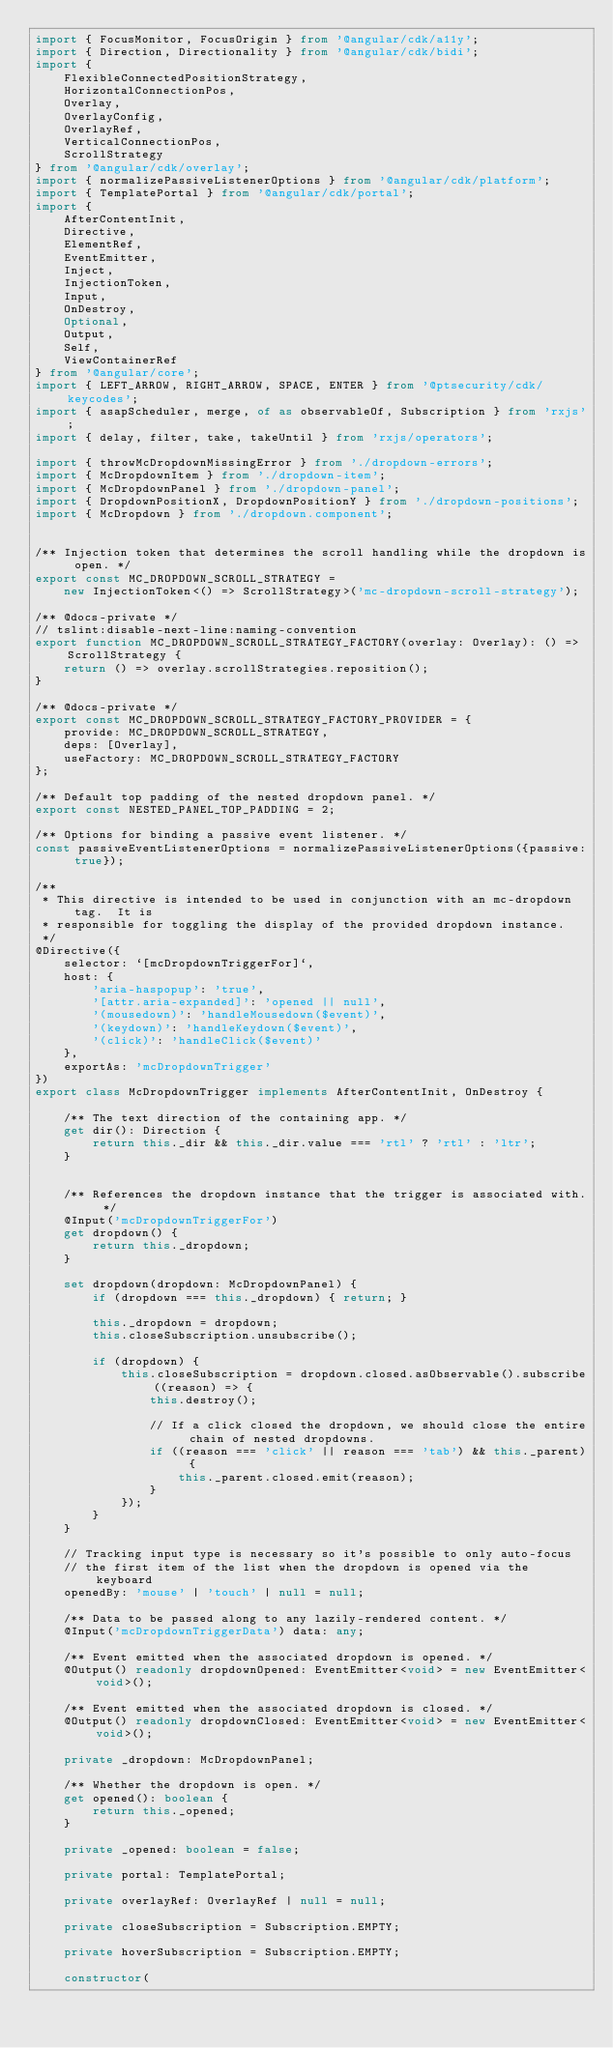<code> <loc_0><loc_0><loc_500><loc_500><_TypeScript_>import { FocusMonitor, FocusOrigin } from '@angular/cdk/a11y';
import { Direction, Directionality } from '@angular/cdk/bidi';
import {
    FlexibleConnectedPositionStrategy,
    HorizontalConnectionPos,
    Overlay,
    OverlayConfig,
    OverlayRef,
    VerticalConnectionPos,
    ScrollStrategy
} from '@angular/cdk/overlay';
import { normalizePassiveListenerOptions } from '@angular/cdk/platform';
import { TemplatePortal } from '@angular/cdk/portal';
import {
    AfterContentInit,
    Directive,
    ElementRef,
    EventEmitter,
    Inject,
    InjectionToken,
    Input,
    OnDestroy,
    Optional,
    Output,
    Self,
    ViewContainerRef
} from '@angular/core';
import { LEFT_ARROW, RIGHT_ARROW, SPACE, ENTER } from '@ptsecurity/cdk/keycodes';
import { asapScheduler, merge, of as observableOf, Subscription } from 'rxjs';
import { delay, filter, take, takeUntil } from 'rxjs/operators';

import { throwMcDropdownMissingError } from './dropdown-errors';
import { McDropdownItem } from './dropdown-item';
import { McDropdownPanel } from './dropdown-panel';
import { DropdownPositionX, DropdownPositionY } from './dropdown-positions';
import { McDropdown } from './dropdown.component';


/** Injection token that determines the scroll handling while the dropdown is open. */
export const MC_DROPDOWN_SCROLL_STRATEGY =
    new InjectionToken<() => ScrollStrategy>('mc-dropdown-scroll-strategy');

/** @docs-private */
// tslint:disable-next-line:naming-convention
export function MC_DROPDOWN_SCROLL_STRATEGY_FACTORY(overlay: Overlay): () => ScrollStrategy {
    return () => overlay.scrollStrategies.reposition();
}

/** @docs-private */
export const MC_DROPDOWN_SCROLL_STRATEGY_FACTORY_PROVIDER = {
    provide: MC_DROPDOWN_SCROLL_STRATEGY,
    deps: [Overlay],
    useFactory: MC_DROPDOWN_SCROLL_STRATEGY_FACTORY
};

/** Default top padding of the nested dropdown panel. */
export const NESTED_PANEL_TOP_PADDING = 2;

/** Options for binding a passive event listener. */
const passiveEventListenerOptions = normalizePassiveListenerOptions({passive: true});

/**
 * This directive is intended to be used in conjunction with an mc-dropdown tag.  It is
 * responsible for toggling the display of the provided dropdown instance.
 */
@Directive({
    selector: `[mcDropdownTriggerFor]`,
    host: {
        'aria-haspopup': 'true',
        '[attr.aria-expanded]': 'opened || null',
        '(mousedown)': 'handleMousedown($event)',
        '(keydown)': 'handleKeydown($event)',
        '(click)': 'handleClick($event)'
    },
    exportAs: 'mcDropdownTrigger'
})
export class McDropdownTrigger implements AfterContentInit, OnDestroy {

    /** The text direction of the containing app. */
    get dir(): Direction {
        return this._dir && this._dir.value === 'rtl' ? 'rtl' : 'ltr';
    }


    /** References the dropdown instance that the trigger is associated with. */
    @Input('mcDropdownTriggerFor')
    get dropdown() {
        return this._dropdown;
    }

    set dropdown(dropdown: McDropdownPanel) {
        if (dropdown === this._dropdown) { return; }

        this._dropdown = dropdown;
        this.closeSubscription.unsubscribe();

        if (dropdown) {
            this.closeSubscription = dropdown.closed.asObservable().subscribe((reason) => {
                this.destroy();

                // If a click closed the dropdown, we should close the entire chain of nested dropdowns.
                if ((reason === 'click' || reason === 'tab') && this._parent) {
                    this._parent.closed.emit(reason);
                }
            });
        }
    }

    // Tracking input type is necessary so it's possible to only auto-focus
    // the first item of the list when the dropdown is opened via the keyboard
    openedBy: 'mouse' | 'touch' | null = null;

    /** Data to be passed along to any lazily-rendered content. */
    @Input('mcDropdownTriggerData') data: any;

    /** Event emitted when the associated dropdown is opened. */
    @Output() readonly dropdownOpened: EventEmitter<void> = new EventEmitter<void>();

    /** Event emitted when the associated dropdown is closed. */
    @Output() readonly dropdownClosed: EventEmitter<void> = new EventEmitter<void>();

    private _dropdown: McDropdownPanel;

    /** Whether the dropdown is open. */
    get opened(): boolean {
        return this._opened;
    }

    private _opened: boolean = false;

    private portal: TemplatePortal;

    private overlayRef: OverlayRef | null = null;

    private closeSubscription = Subscription.EMPTY;

    private hoverSubscription = Subscription.EMPTY;

    constructor(</code> 